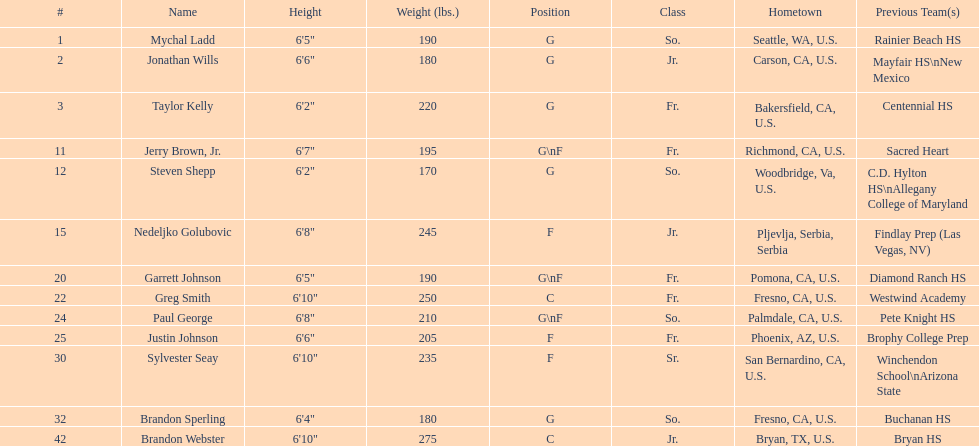Which player is taller, paul george or greg smith? Greg Smith. 